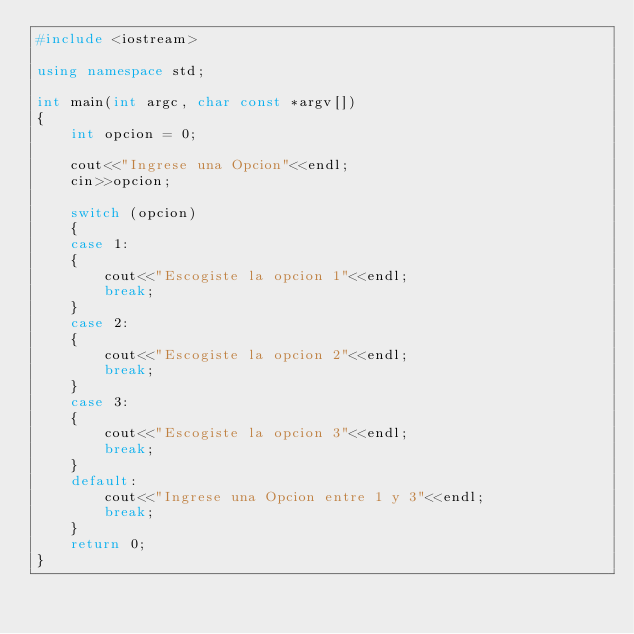<code> <loc_0><loc_0><loc_500><loc_500><_C++_>#include <iostream>

using namespace std;

int main(int argc, char const *argv[])
{
    int opcion = 0;

    cout<<"Ingrese una Opcion"<<endl;
    cin>>opcion;

    switch (opcion)
    {
    case 1:
    {
        cout<<"Escogiste la opcion 1"<<endl;
        break;
    }
    case 2:
    {
        cout<<"Escogiste la opcion 2"<<endl;
        break;    
    }
    case 3:
    {
        cout<<"Escogiste la opcion 3"<<endl;
        break;
    }
    default:
        cout<<"Ingrese una Opcion entre 1 y 3"<<endl;
        break;
    }
    return 0;
}
</code> 